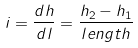Convert formula to latex. <formula><loc_0><loc_0><loc_500><loc_500>i = \frac { d h } { d l } = \frac { h _ { 2 } - h _ { 1 } } { l e n g t h }</formula> 